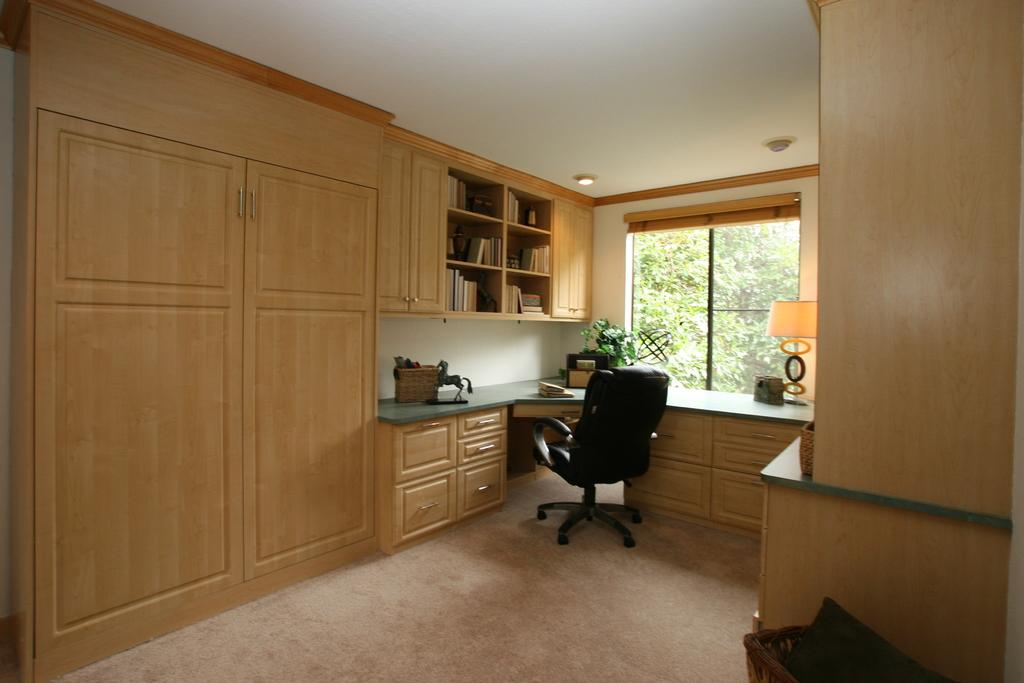What type of furniture is on the floor in the image? There is a chair on the floor in the image. What type of plant is in the image? There is a house plant in the image. What type of lighting is in the image? There is a lamp in the image. How are the books arranged in the image? The books are in racks in the image. What type of storage is in the image? There are cupboards in the image. What can be seen through the window in the image? Trees are visible through the window in the image. How many pigs are visible in the image in the image? There are no pigs present in the image. What type of view can be seen from the window in the image? The view through the window in the image is of trees, not a specific type of view like a cityscape or a beach. 